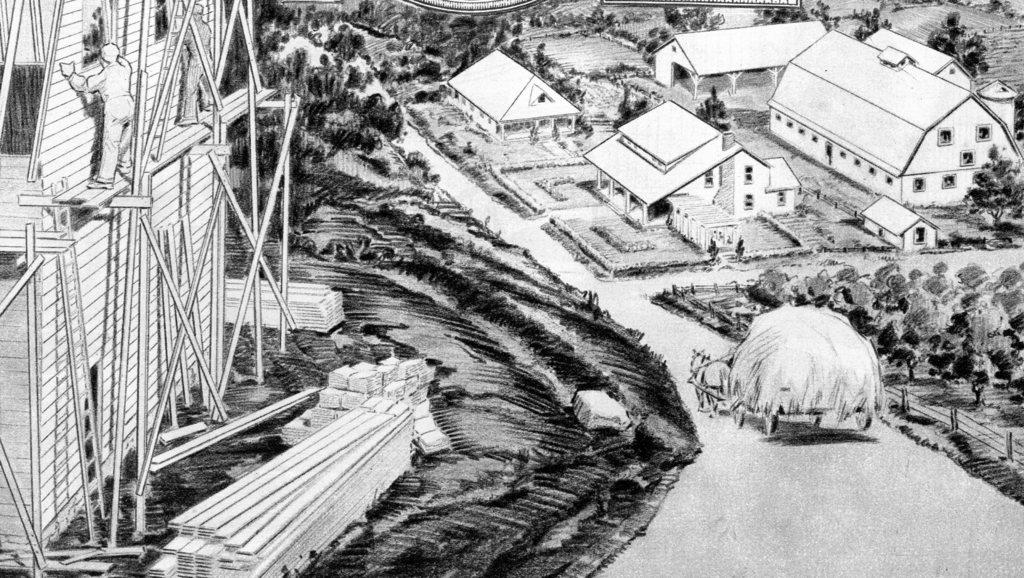What is the color scheme of the image? The image is black and white and animated. What type of natural elements can be seen in the image? There are trees in the image. What type of buildings are present in the image? There are houses in the image. What mode of transportation can be seen in the image? There is a horse cart in the image. What construction activity is taking place in the image? There is a house construction on the left side of the image. What material is used for the construction in the image? There are wooden planks in the image. Can you tell me how many basketballs are being used as a reward for the servant in the image? There are no basketballs or servants present in the image. 